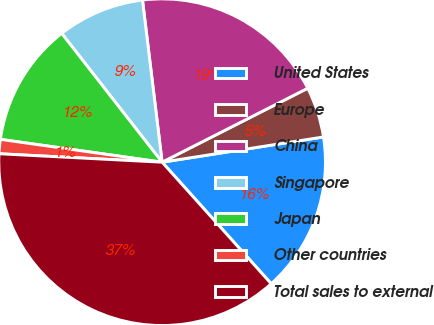Convert chart. <chart><loc_0><loc_0><loc_500><loc_500><pie_chart><fcel>United States<fcel>Europe<fcel>China<fcel>Singapore<fcel>Japan<fcel>Other countries<fcel>Total sales to external<nl><fcel>15.83%<fcel>5.01%<fcel>19.44%<fcel>8.62%<fcel>12.23%<fcel>1.41%<fcel>37.47%<nl></chart> 